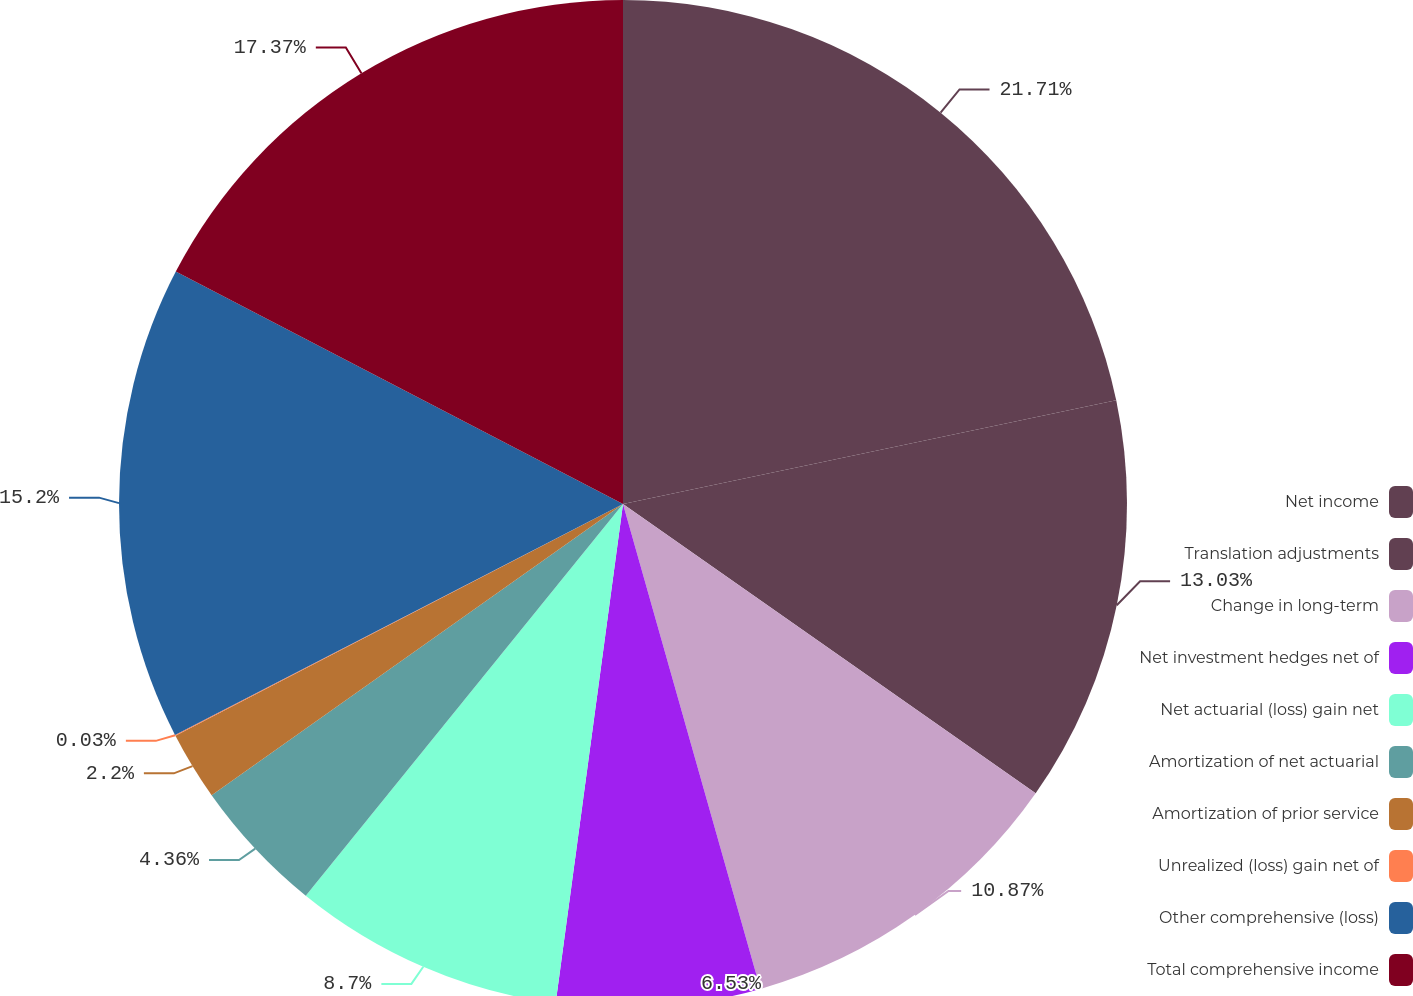Convert chart. <chart><loc_0><loc_0><loc_500><loc_500><pie_chart><fcel>Net income<fcel>Translation adjustments<fcel>Change in long-term<fcel>Net investment hedges net of<fcel>Net actuarial (loss) gain net<fcel>Amortization of net actuarial<fcel>Amortization of prior service<fcel>Unrealized (loss) gain net of<fcel>Other comprehensive (loss)<fcel>Total comprehensive income<nl><fcel>21.7%<fcel>13.03%<fcel>10.87%<fcel>6.53%<fcel>8.7%<fcel>4.36%<fcel>2.2%<fcel>0.03%<fcel>15.2%<fcel>17.37%<nl></chart> 